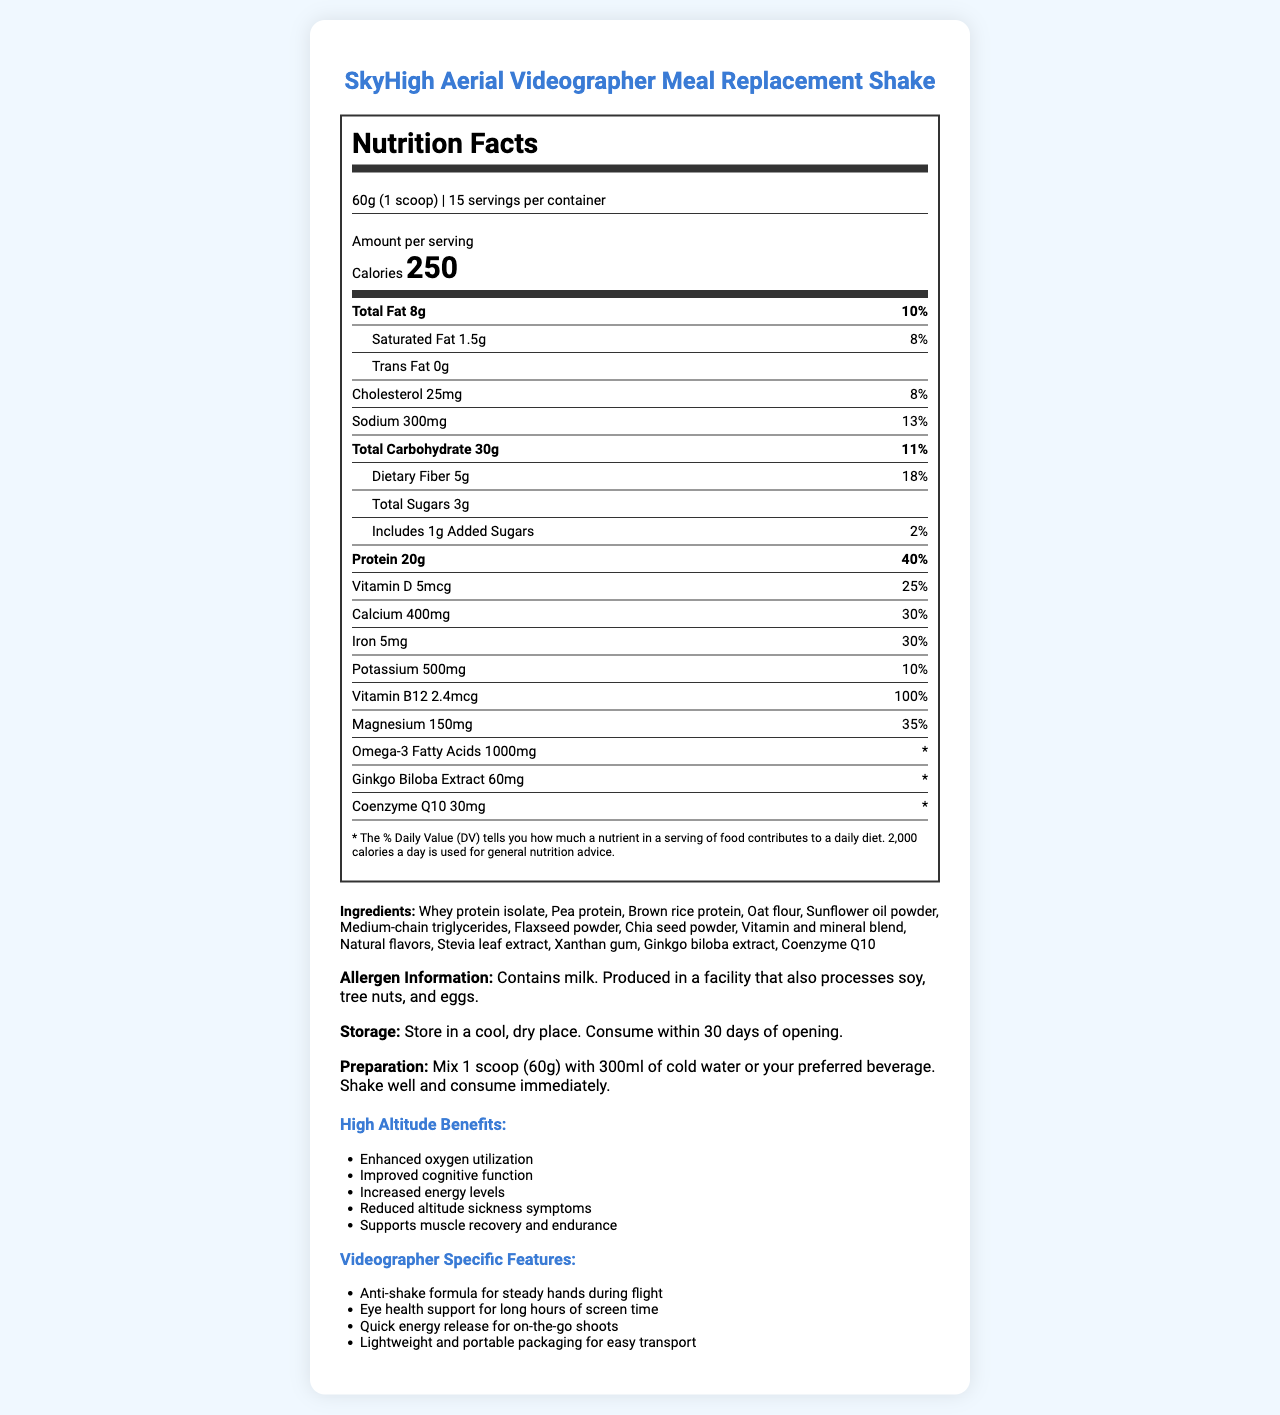what is the serving size? The serving size information is provided at the top of the document under the heading "serving_info."
Answer: 60g (1 scoop) how many servings are in the container? The number of servings per container is listed as 15.
Answer: 15 servings how many calories are in one serving? The amount of calories per serving is displayed prominently in the "calorie_info" section.
Answer: 250 calories how much protein is in one serving and what percentage of the daily value does it provide? The protein content (20g) and its daily value percentage (40%) are shown in the nutrient information section under protein.
Answer: 20g, 40% which allergen does the product contain? The allergen info indicates that the product contains milk and is produced in a facility that processes soy, tree nuts, and eggs.
Answer: Milk what is the total fat content per serving? The total fat content per serving is listed as 8g in the nutrient information section under total fat.
Answer: 8g what are the high-altitude benefits of this product? The high-altitude benefits are listed under the heading "High Altitude Benefits."
Answer: Enhanced oxygen utilization, Improved cognitive function, Increased energy levels, Reduced altitude sickness symptoms, Supports muscle recovery and endurance which vitamin has a daily value percentage of 100%? The nutrient information shows that Vitamin B12 provides 100% of the daily value.
Answer: Vitamin B12 how much magnesium is in each serving and what percentage of the daily value does it contribute? The nutrient information lists magnesium as having 150mg per serving, contributing 35% of the daily value.
Answer: 150mg, 35% how much sodium does each serving contain? The sodium content per serving is indicated as 300mg in the nutrient information section.
Answer: 300mg True or False: This product contains omega-3 fatty acids. The nutrient information section lists omega-3 fatty acids with an amount of 1000mg.
Answer: True which of the following are included in the high-altitude benefits? A. Improved sleep B. Enhanced oxygen utilization C. Reduced appetite The high-altitude benefits list includes "Enhanced oxygen utilization" but not "Improved sleep" or "Reduced appetite."
Answer: B which ingredient is not in the product? I. Whey protein isolate II. Sunflower oil powder III. Soy protein The ingredients list includes Whey protein isolate and Sunflower oil powder but does not include Soy protein.
Answer: III can you store this product in a humid environment? The storage instructions advise storing the product in a cool, dry place.
Answer: No summarize the document's main idea. The document's main sections cover nutrition facts, high-altitude benefits, videographer-specific features, ingredients, allergen information, storage, and preparation instructions.
Answer: The document provides detailed nutrition facts and features of the SkyHigh Aerial Videographer Meal Replacement Shake, highlighting its benefits for high-altitude conditions and specific features for videographers. It includes serving size, nutrient breakdown, ingredients, allergen info, storage, and preparation instructions. does the product help to avoid jet lag? The document doesn't mention anything about jet lag; it focuses on high-altitude benefits and features for videographers, not jet lag.
Answer: Cannot be determined 